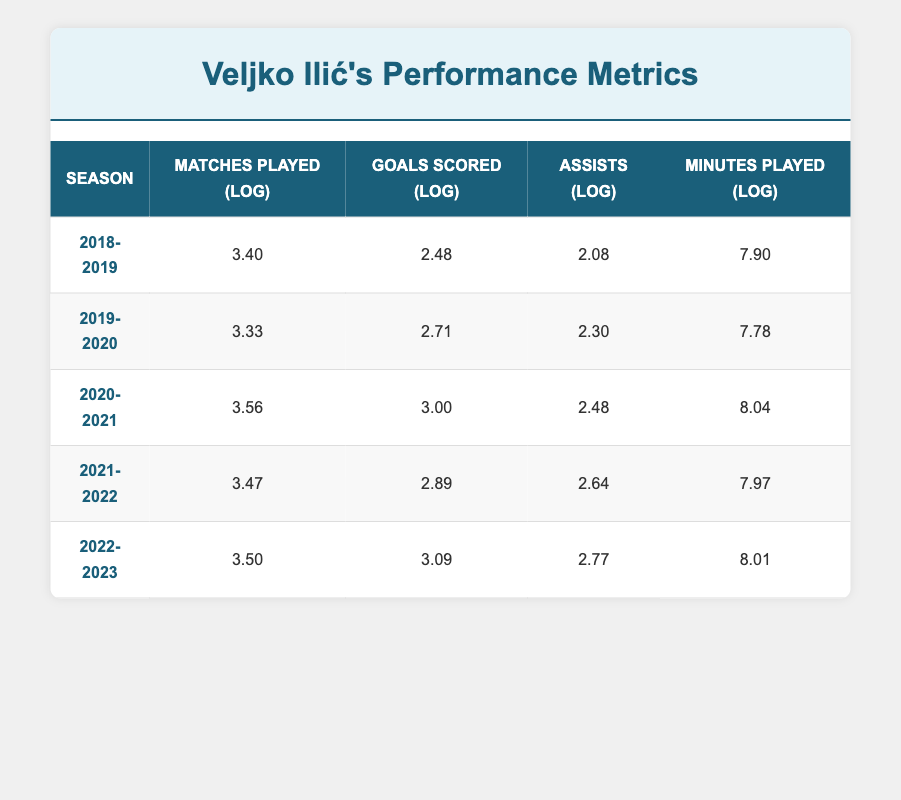What was the highest number of goals scored by Veljko Ilić in a season? Reviewing the 'Goals Scored' column in the table, the highest value is 3.09 in the 2022-2023 season.
Answer: 3.09 In which season did Veljko Ilić play the most matches? By analyzing the 'Matches Played' column, the highest value is 3.56 corresponding to the 2020-2021 season where he played 35 matches.
Answer: 2020-2021 What is the average number of assists over the last five seasons? The total number of assists is 8 + 10 + 12 + 14 + 16 = 60. There are 5 seasons, so the average assists are 60 / 5 = 12.
Answer: 12 Did Veljko Ilić score more goals in 2020-2021 than in 2021-2022? Comparing the 'Goals Scored' for the two seasons shows that he scored 3.00 in 2020-2021 and 2.89 in 2021-2022, which confirms that he scored more in 2020-2021.
Answer: Yes What was the change in minutes played from the 2019-2020 season to the 2022-2023 season? The minutes played in 2019-2020 is 7.78 and for 2022-2023, it is 8.01. The change is 8.01 - 7.78 = 0.23, indicating an increase.
Answer: 0.23 In which season did Veljko Ilić achieve the highest assists per match played? To find this, divide the assists by matches played for each season. Calculating shows that 16 assists in 33 matches in 2022-2023 gives 0.48, which is the highest.
Answer: 2022-2023 Are the total minutes played in 2021-2022 greater than the total in 2018-2019? Checking the 'Minutes Played' values, we see 7.97 for 2021-2022 and 7.90 for 2018-2019, which shows that 2021-2022 has more minutes played.
Answer: Yes What was the difference in logarithmic values for goals scored between the 2020-2021 and 2021-2022 seasons? The values are 3.00 for 2020-2021 and 2.89 for 2021-2022. The difference is 3.00 - 2.89 = 0.11, indicating a small decrease in that year.
Answer: 0.11 